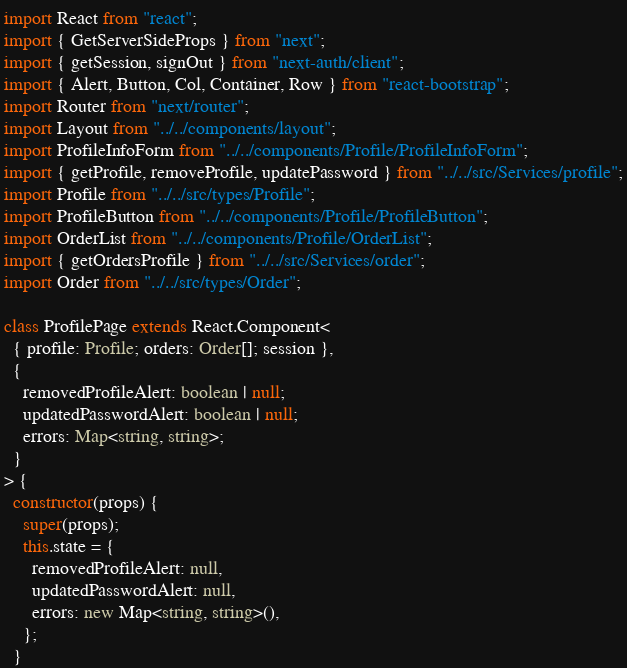Convert code to text. <code><loc_0><loc_0><loc_500><loc_500><_TypeScript_>import React from "react";
import { GetServerSideProps } from "next";
import { getSession, signOut } from "next-auth/client";
import { Alert, Button, Col, Container, Row } from "react-bootstrap";
import Router from "next/router";
import Layout from "../../components/layout";
import ProfileInfoForm from "../../components/Profile/ProfileInfoForm";
import { getProfile, removeProfile, updatePassword } from "../../src/Services/profile";
import Profile from "../../src/types/Profile";
import ProfileButton from "../../components/Profile/ProfileButton";
import OrderList from "../../components/Profile/OrderList";
import { getOrdersProfile } from "../../src/Services/order";
import Order from "../../src/types/Order";

class ProfilePage extends React.Component<
  { profile: Profile; orders: Order[]; session },
  {
    removedProfileAlert: boolean | null;
    updatedPasswordAlert: boolean | null;
    errors: Map<string, string>;
  }
> {
  constructor(props) {
    super(props);
    this.state = {
      removedProfileAlert: null,
      updatedPasswordAlert: null,
      errors: new Map<string, string>(),
    };
  }
</code> 